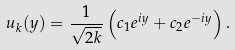<formula> <loc_0><loc_0><loc_500><loc_500>u _ { k } ( y ) = \frac { 1 } { \sqrt { 2 k } } \left ( c _ { 1 } e ^ { i y } + c _ { 2 } e ^ { - i y } \right ) .</formula> 